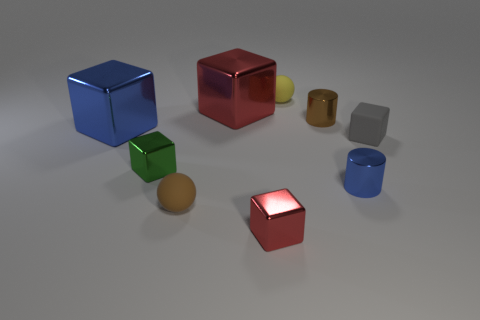Subtract all blue cubes. How many cubes are left? 4 Subtract all small green metallic cubes. How many cubes are left? 4 Subtract 2 blocks. How many blocks are left? 3 Subtract all green blocks. Subtract all red cylinders. How many blocks are left? 4 Add 1 large red shiny objects. How many objects exist? 10 Subtract all cylinders. How many objects are left? 7 Add 6 small blocks. How many small blocks exist? 9 Subtract 1 blue cubes. How many objects are left? 8 Subtract all big red rubber cylinders. Subtract all blue shiny objects. How many objects are left? 7 Add 8 tiny red cubes. How many tiny red cubes are left? 9 